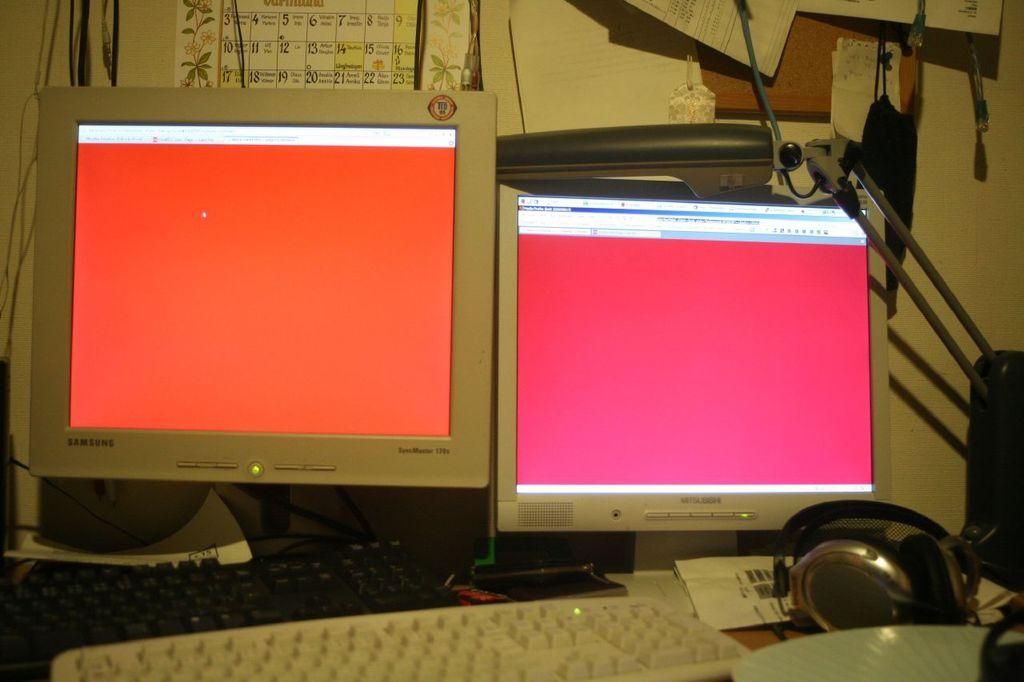What brand of monitor is on the left?
Your response must be concise. Samsung. Is it apple or pc?
Keep it short and to the point. Pc. 